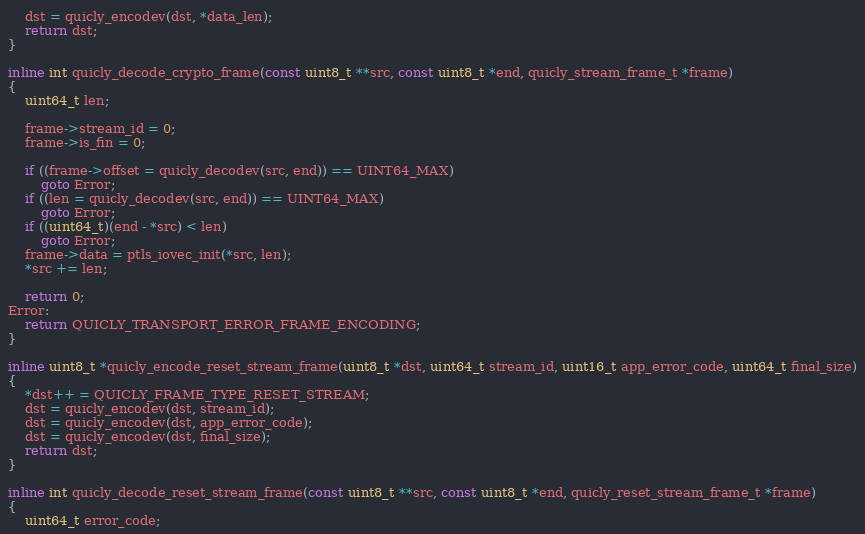<code> <loc_0><loc_0><loc_500><loc_500><_C_>    dst = quicly_encodev(dst, *data_len);
    return dst;
}

inline int quicly_decode_crypto_frame(const uint8_t **src, const uint8_t *end, quicly_stream_frame_t *frame)
{
    uint64_t len;

    frame->stream_id = 0;
    frame->is_fin = 0;

    if ((frame->offset = quicly_decodev(src, end)) == UINT64_MAX)
        goto Error;
    if ((len = quicly_decodev(src, end)) == UINT64_MAX)
        goto Error;
    if ((uint64_t)(end - *src) < len)
        goto Error;
    frame->data = ptls_iovec_init(*src, len);
    *src += len;

    return 0;
Error:
    return QUICLY_TRANSPORT_ERROR_FRAME_ENCODING;
}

inline uint8_t *quicly_encode_reset_stream_frame(uint8_t *dst, uint64_t stream_id, uint16_t app_error_code, uint64_t final_size)
{
    *dst++ = QUICLY_FRAME_TYPE_RESET_STREAM;
    dst = quicly_encodev(dst, stream_id);
    dst = quicly_encodev(dst, app_error_code);
    dst = quicly_encodev(dst, final_size);
    return dst;
}

inline int quicly_decode_reset_stream_frame(const uint8_t **src, const uint8_t *end, quicly_reset_stream_frame_t *frame)
{
    uint64_t error_code;
</code> 